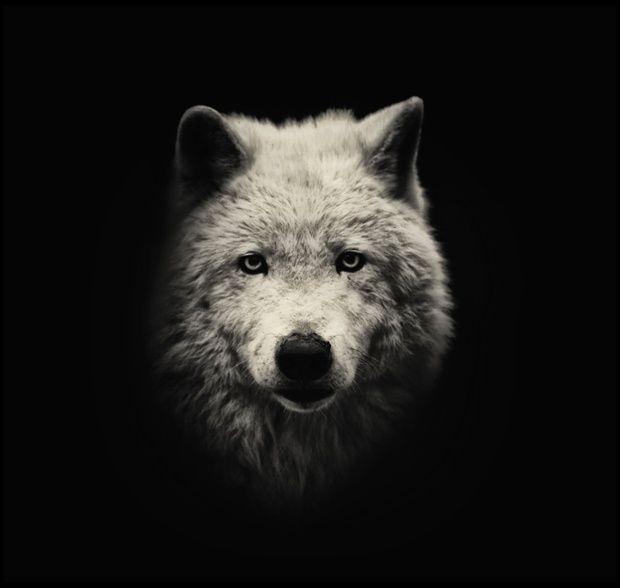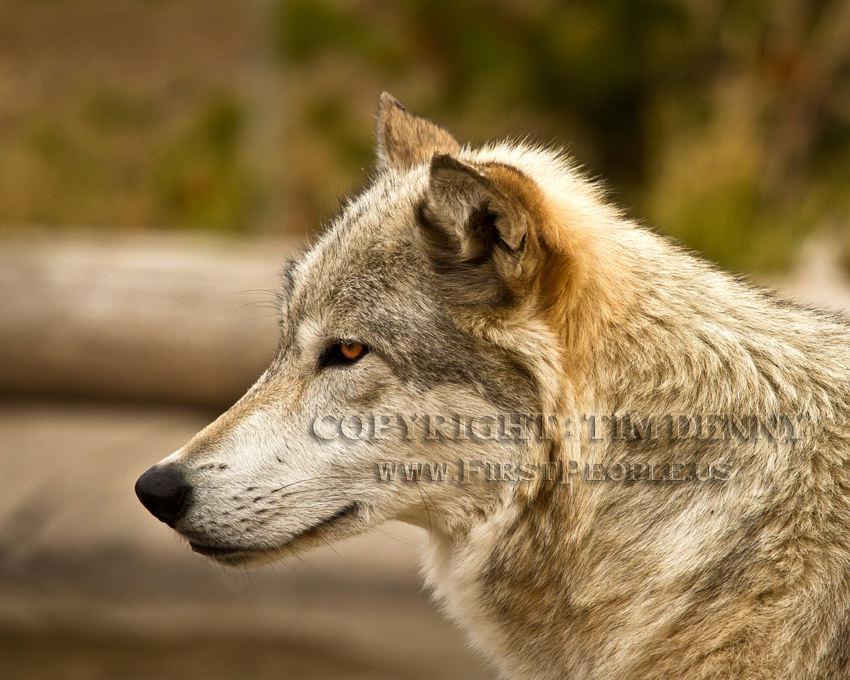The first image is the image on the left, the second image is the image on the right. Examine the images to the left and right. Is the description "At least one image shows a wolf baring its fangs." accurate? Answer yes or no. No. The first image is the image on the left, the second image is the image on the right. Assess this claim about the two images: "The dog on the right is baring its teeth.". Correct or not? Answer yes or no. No. 